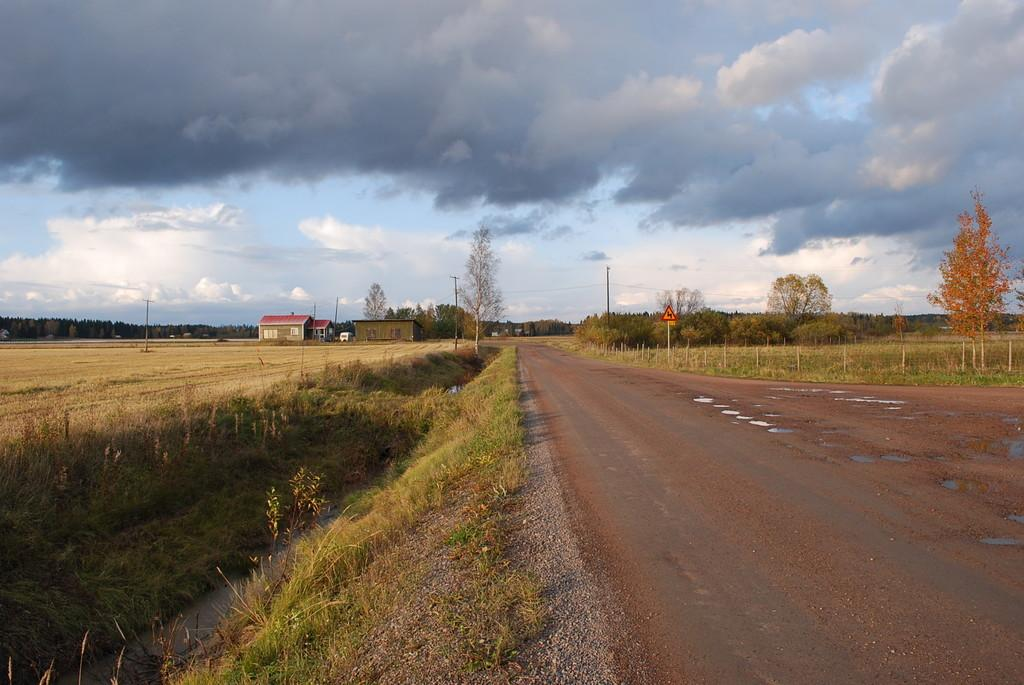What type of vegetation can be seen in the image? There are plants and grass visible in the image. What type of pathway is present in the image? There is a road in the image. What is the water feature in the image? There is water visible in the image. What structure is on a pole in the image? There is a board on a pole in the image. What type of poles are present in the image? There are poles in the image. What can be seen in the background of the image? In the background, there are current polls, houses, trees, and the sky with clouds. Who is the owner of the bag seen in the image? There is no bag present in the image, so it is not possible to determine the owner. What is the porter carrying in the image? There is no porter present in the image, so it is not possible to determine what they might be carrying. 